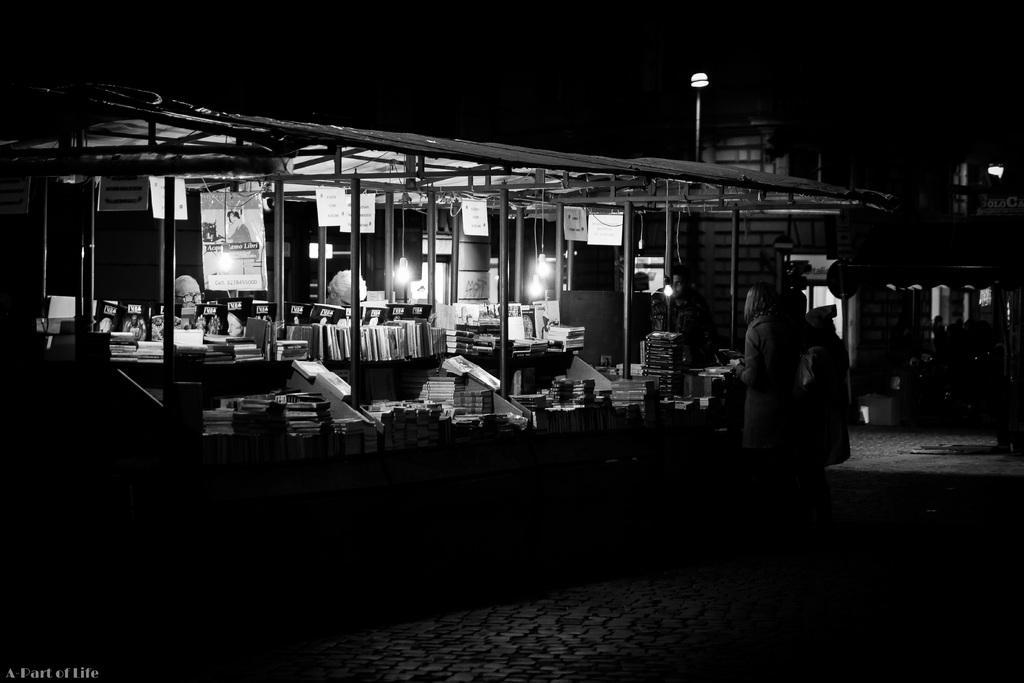In one or two sentences, can you explain what this image depicts? Here we can see black and white image. In the image we can see there are people standing and wearing clothes. Here we can see books, pole tent, lights, footpath and dark sky. On the bottom left we can see watermark.  